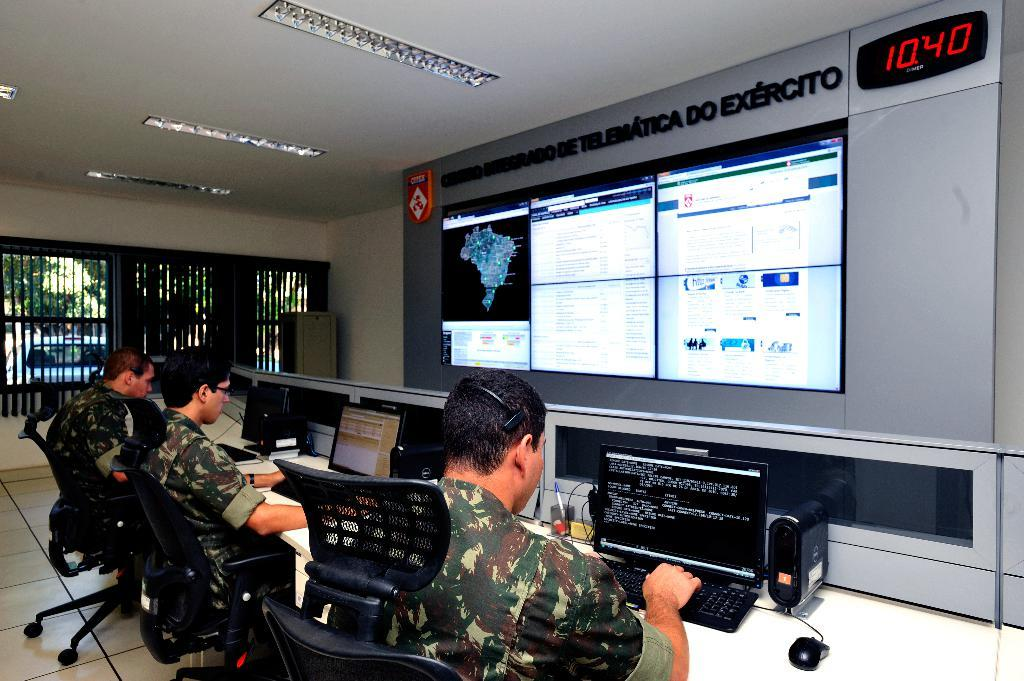<image>
Render a clear and concise summary of the photo. Three people sits at in front of a large screen with a clock in the corner that reads 1040. 